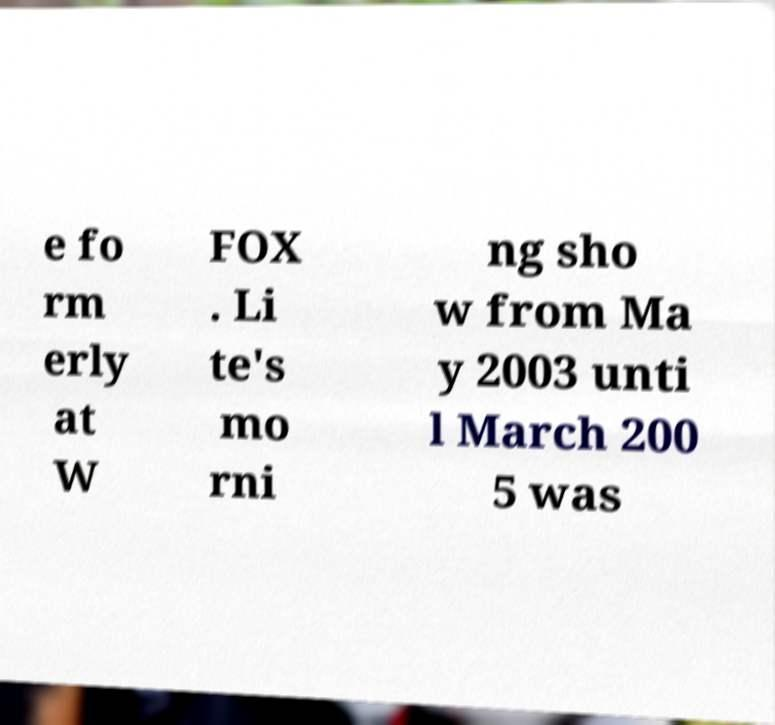There's text embedded in this image that I need extracted. Can you transcribe it verbatim? e fo rm erly at W FOX . Li te's mo rni ng sho w from Ma y 2003 unti l March 200 5 was 